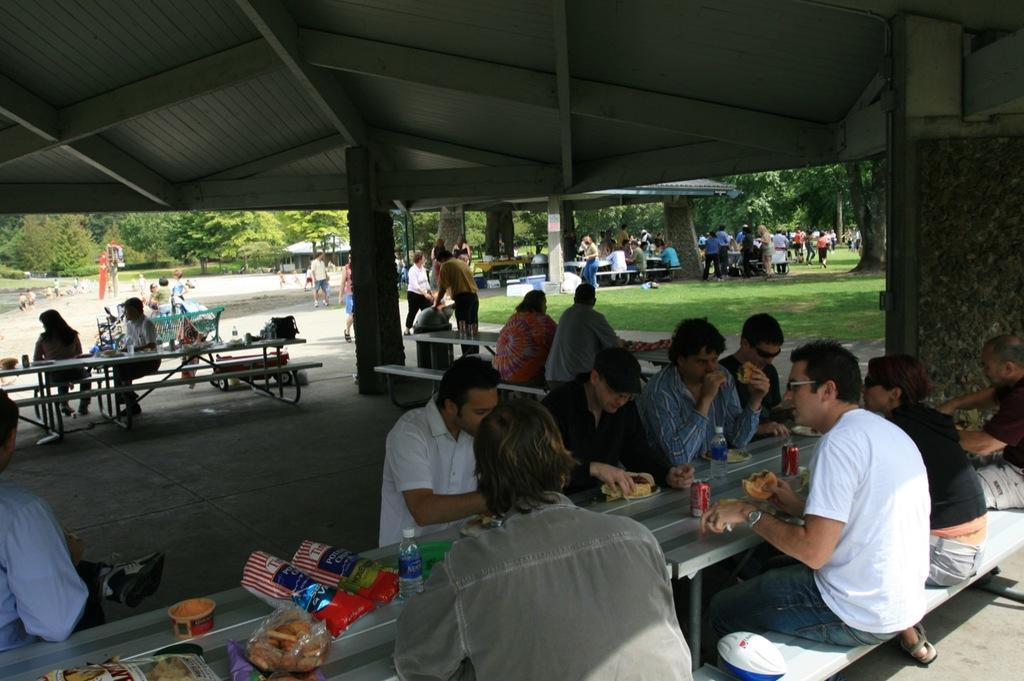Please provide a concise description of this image. There are some people sitting on the bench and eating. There is a coke on the table and some food item on the tables. There are some people out are also standing. And we can see trees at the background and grass at the bottom. 